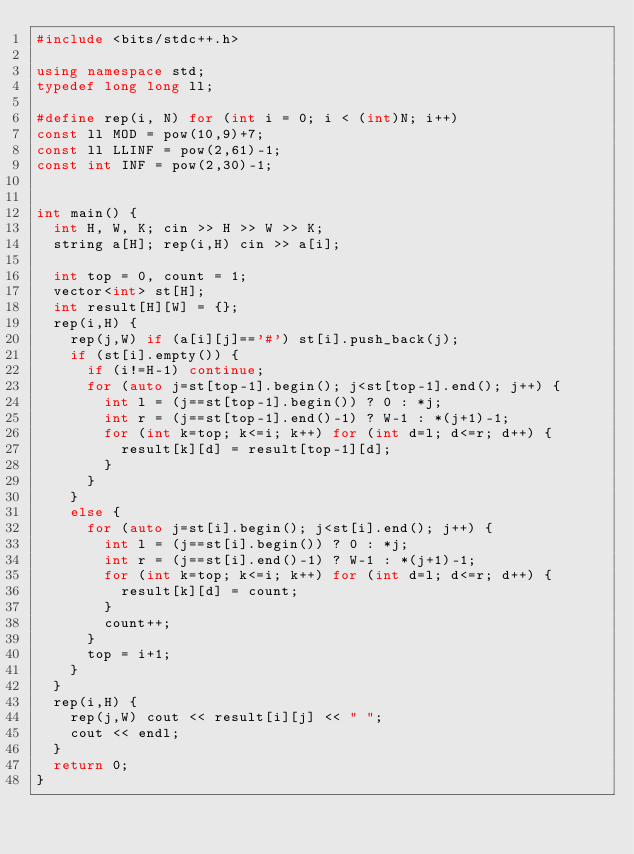<code> <loc_0><loc_0><loc_500><loc_500><_C++_>#include <bits/stdc++.h>

using namespace std;
typedef long long ll;

#define rep(i, N) for (int i = 0; i < (int)N; i++)
const ll MOD = pow(10,9)+7;
const ll LLINF = pow(2,61)-1;
const int INF = pow(2,30)-1;


int main() {
  int H, W, K; cin >> H >> W >> K;
  string a[H]; rep(i,H) cin >> a[i];

  int top = 0, count = 1;
  vector<int> st[H];
  int result[H][W] = {};
  rep(i,H) {
    rep(j,W) if (a[i][j]=='#') st[i].push_back(j);
    if (st[i].empty()) {
      if (i!=H-1) continue;
      for (auto j=st[top-1].begin(); j<st[top-1].end(); j++) {
        int l = (j==st[top-1].begin()) ? 0 : *j;
        int r = (j==st[top-1].end()-1) ? W-1 : *(j+1)-1;
        for (int k=top; k<=i; k++) for (int d=l; d<=r; d++) {
          result[k][d] = result[top-1][d];
        }
      }
    }
    else {
      for (auto j=st[i].begin(); j<st[i].end(); j++) {
        int l = (j==st[i].begin()) ? 0 : *j;
        int r = (j==st[i].end()-1) ? W-1 : *(j+1)-1;
        for (int k=top; k<=i; k++) for (int d=l; d<=r; d++) {
          result[k][d] = count;
        }
        count++;
      }
      top = i+1;
    }
  }
  rep(i,H) {
    rep(j,W) cout << result[i][j] << " ";
    cout << endl;
  }
  return 0;
}</code> 